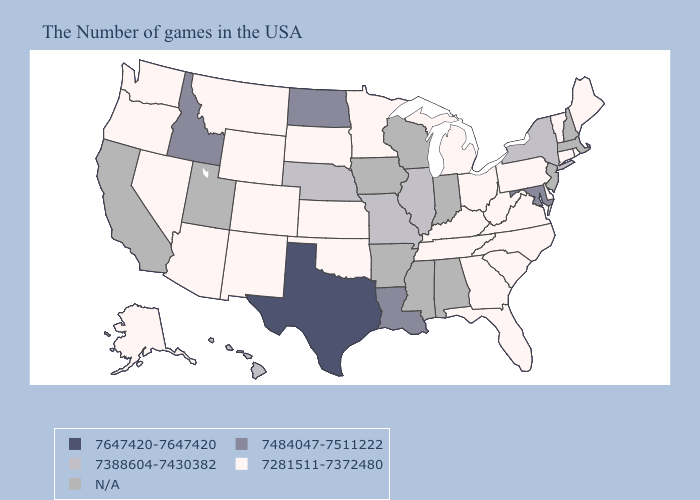Does the map have missing data?
Be succinct. Yes. What is the lowest value in states that border Texas?
Be succinct. 7281511-7372480. Name the states that have a value in the range 7647420-7647420?
Quick response, please. Texas. Does Arizona have the lowest value in the USA?
Answer briefly. Yes. Among the states that border Tennessee , does Missouri have the highest value?
Keep it brief. Yes. What is the highest value in states that border Mississippi?
Concise answer only. 7484047-7511222. Name the states that have a value in the range 7281511-7372480?
Answer briefly. Maine, Rhode Island, Vermont, Connecticut, Delaware, Pennsylvania, Virginia, North Carolina, South Carolina, West Virginia, Ohio, Florida, Georgia, Michigan, Kentucky, Tennessee, Minnesota, Kansas, Oklahoma, South Dakota, Wyoming, Colorado, New Mexico, Montana, Arizona, Nevada, Washington, Oregon, Alaska. What is the value of Mississippi?
Give a very brief answer. N/A. Name the states that have a value in the range 7647420-7647420?
Short answer required. Texas. Name the states that have a value in the range 7281511-7372480?
Short answer required. Maine, Rhode Island, Vermont, Connecticut, Delaware, Pennsylvania, Virginia, North Carolina, South Carolina, West Virginia, Ohio, Florida, Georgia, Michigan, Kentucky, Tennessee, Minnesota, Kansas, Oklahoma, South Dakota, Wyoming, Colorado, New Mexico, Montana, Arizona, Nevada, Washington, Oregon, Alaska. What is the value of Nevada?
Short answer required. 7281511-7372480. Among the states that border Delaware , does Maryland have the lowest value?
Answer briefly. No. Name the states that have a value in the range 7281511-7372480?
Keep it brief. Maine, Rhode Island, Vermont, Connecticut, Delaware, Pennsylvania, Virginia, North Carolina, South Carolina, West Virginia, Ohio, Florida, Georgia, Michigan, Kentucky, Tennessee, Minnesota, Kansas, Oklahoma, South Dakota, Wyoming, Colorado, New Mexico, Montana, Arizona, Nevada, Washington, Oregon, Alaska. Which states have the highest value in the USA?
Give a very brief answer. Texas. How many symbols are there in the legend?
Answer briefly. 5. 